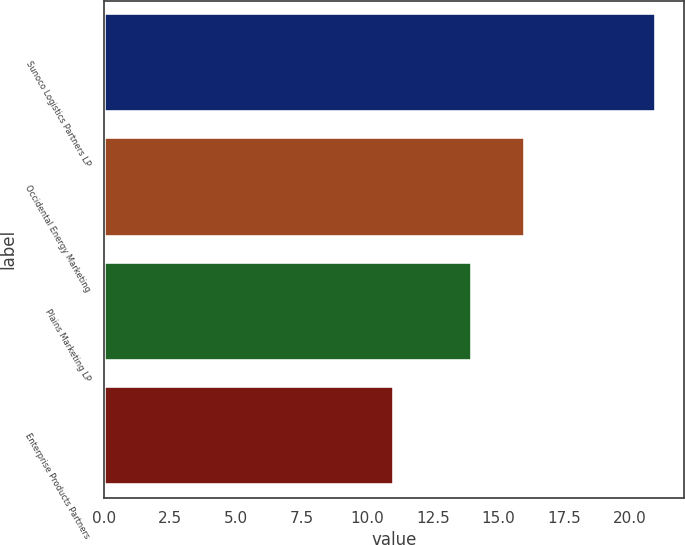Convert chart to OTSL. <chart><loc_0><loc_0><loc_500><loc_500><bar_chart><fcel>Sunoco Logistics Partners LP<fcel>Occidental Energy Marketing<fcel>Plains Marketing LP<fcel>Enterprise Products Partners<nl><fcel>21<fcel>16<fcel>14<fcel>11<nl></chart> 